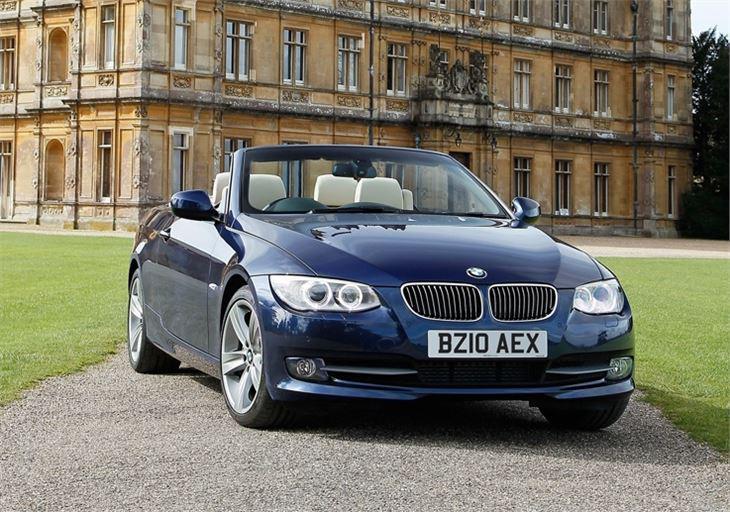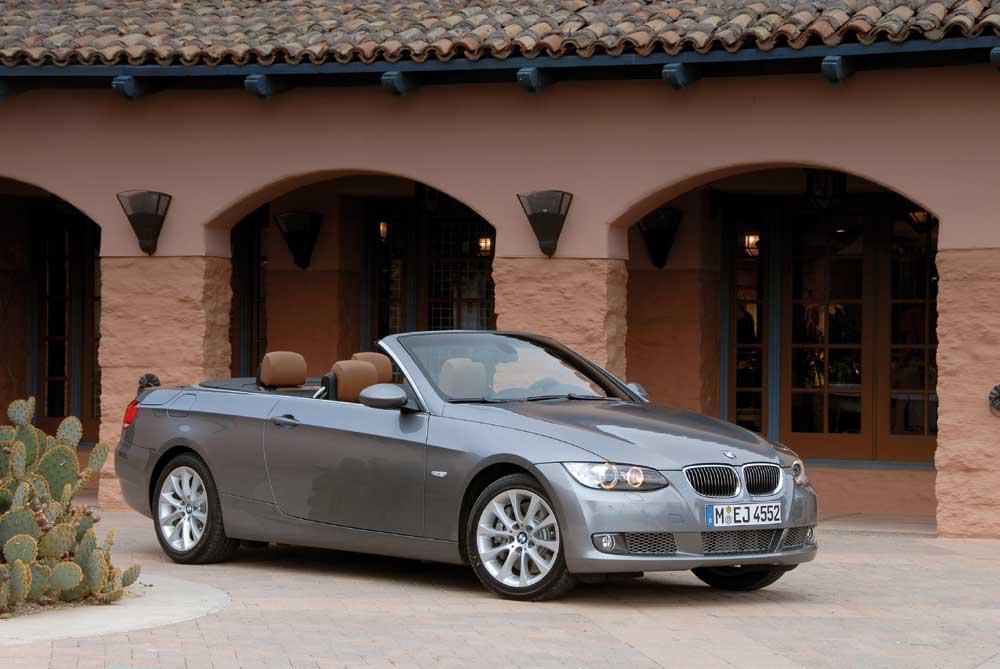The first image is the image on the left, the second image is the image on the right. Examine the images to the left and right. Is the description "An image shows a parked deep blue convertible with noone inside it." accurate? Answer yes or no. Yes. The first image is the image on the left, the second image is the image on the right. Assess this claim about the two images: "Two convertible sports cars are parked so that their license plates are visible, one blue with white seat headrests and one silver metallic.". Correct or not? Answer yes or no. Yes. 